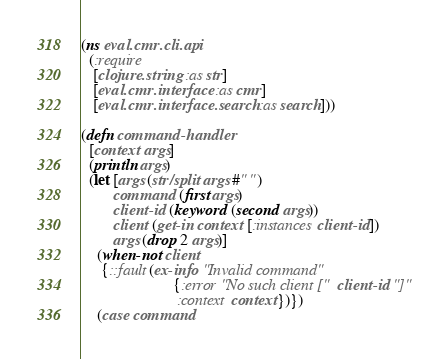<code> <loc_0><loc_0><loc_500><loc_500><_Clojure_>(ns eval.cmr.cli.api
  (:require
   [clojure.string :as str]
   [eval.cmr.interface :as cmr]
   [eval.cmr.interface.search :as search]))

(defn command-handler
  [context args]
  (println args)
  (let [args (str/split args #" ")
        command (first args)
        client-id (keyword (second args))
        client (get-in context [:instances client-id])
        args (drop 2 args)]
    (when-not client
     {::fault (ex-info "Invalid command"
                       {:error "No such client [" client-id "]"
                        :context context})})
    (case command</code> 